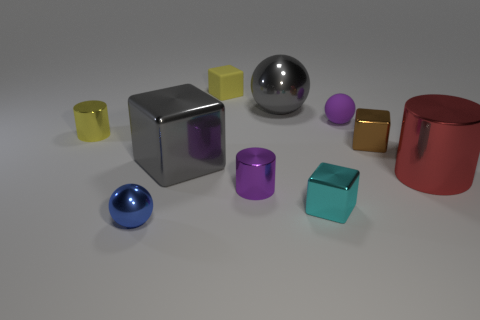Subtract all small cylinders. How many cylinders are left? 1 Subtract all cylinders. How many objects are left? 7 Subtract all brown cubes. How many cubes are left? 3 Subtract 3 cylinders. How many cylinders are left? 0 Subtract all rubber objects. Subtract all tiny brown objects. How many objects are left? 7 Add 5 blocks. How many blocks are left? 9 Add 9 large red shiny things. How many large red shiny things exist? 10 Subtract 0 blue blocks. How many objects are left? 10 Subtract all cyan blocks. Subtract all red cylinders. How many blocks are left? 3 